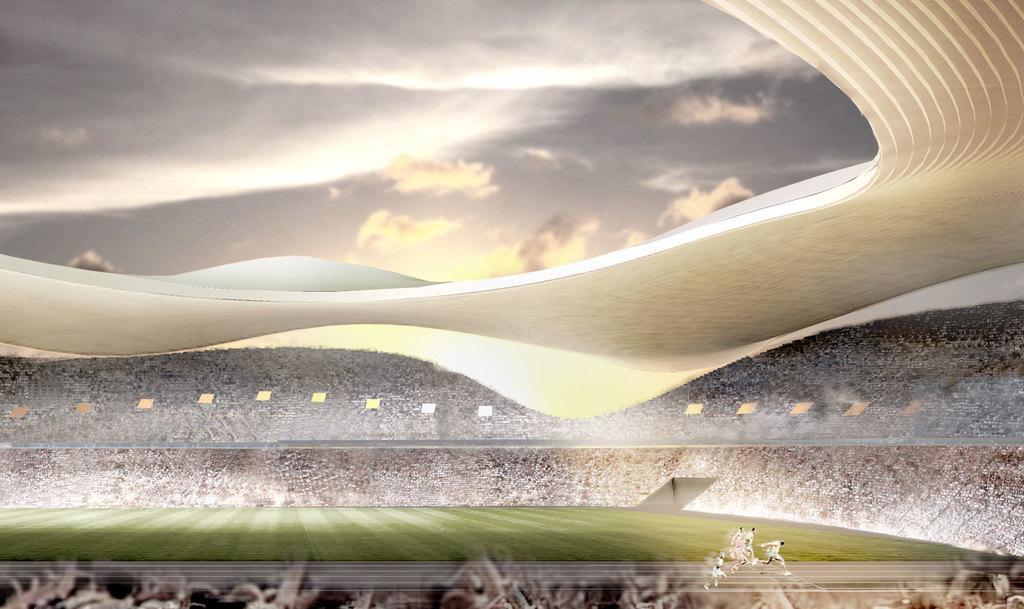Please provide a concise description of this image. In this image, we can see the stadium. There are a few people. We can see the ground covered with grass. We can also see a white colored object on the top. We can see the sky with clouds. 